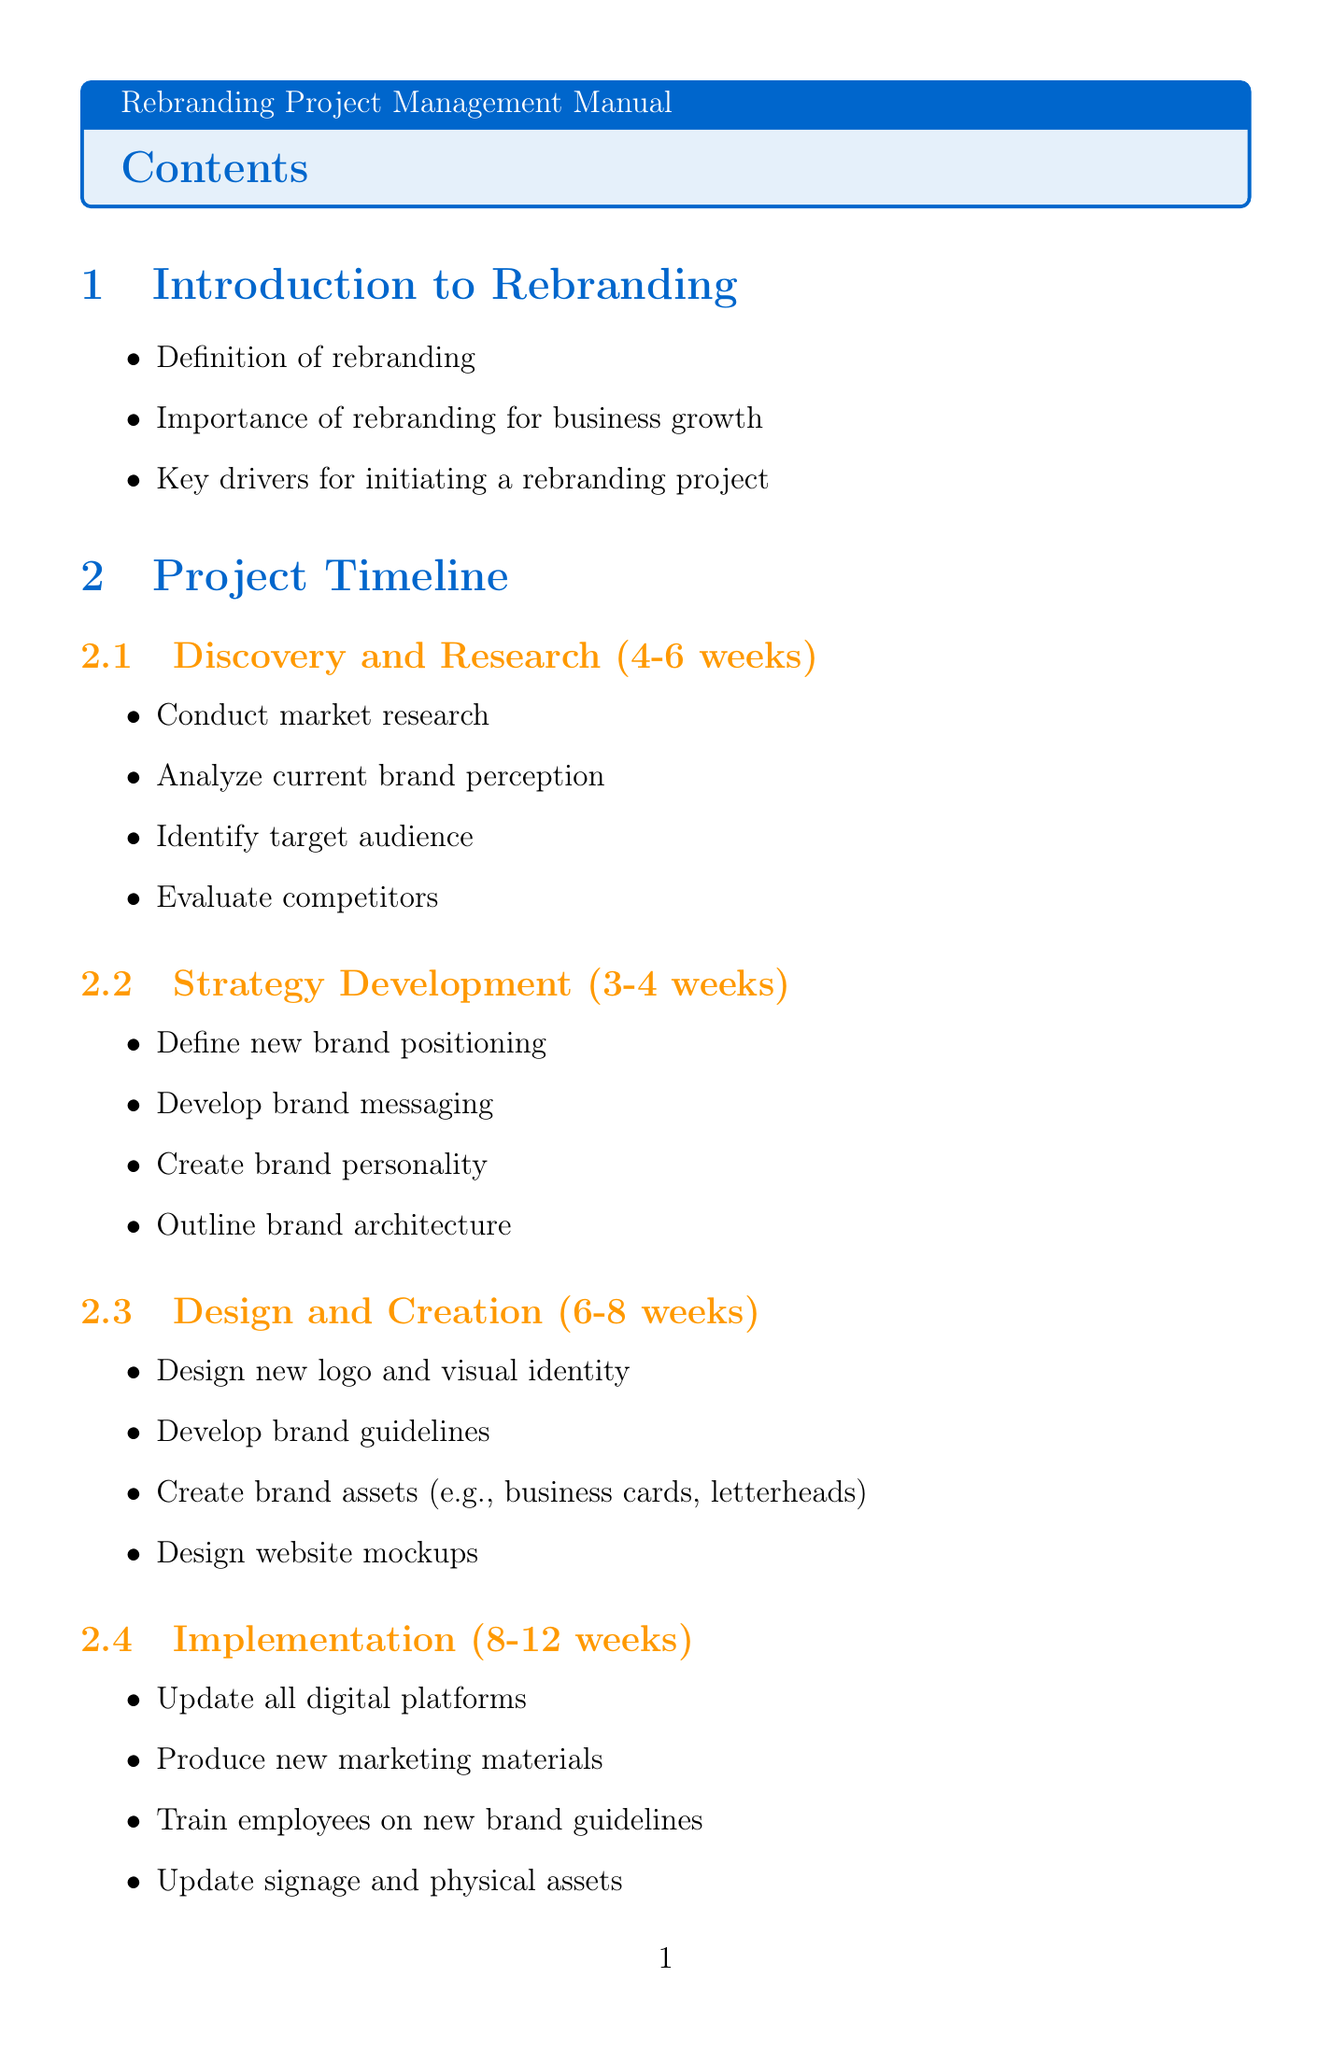What is the duration of the Discovery and Research phase? The duration is specified in the document as 4-6 weeks for this phase.
Answer: 4-6 weeks Who is responsible for developing brand strategy? The document lists the Brand Strategist as the one responsible for developing brand strategy.
Answer: Brand Strategist What tool is used for project management and task tracking? The document states that Asana is used for project management and task tracking.
Answer: Asana How many key performance indicators are listed for measuring success? The document enumerates a total of seven key performance indicators for measuring success.
Answer: seven What risk is associated with negative customer reaction? According to the document, the mitigation strategy for negative customer reaction is to conduct thorough market research and soft launch.
Answer: Conduct thorough market research and soft launch What is the primary purpose of Adobe Creative Suite? The document indicates that Adobe Creative Suite is primarily used for design and asset creation.
Answer: Design and asset creation 